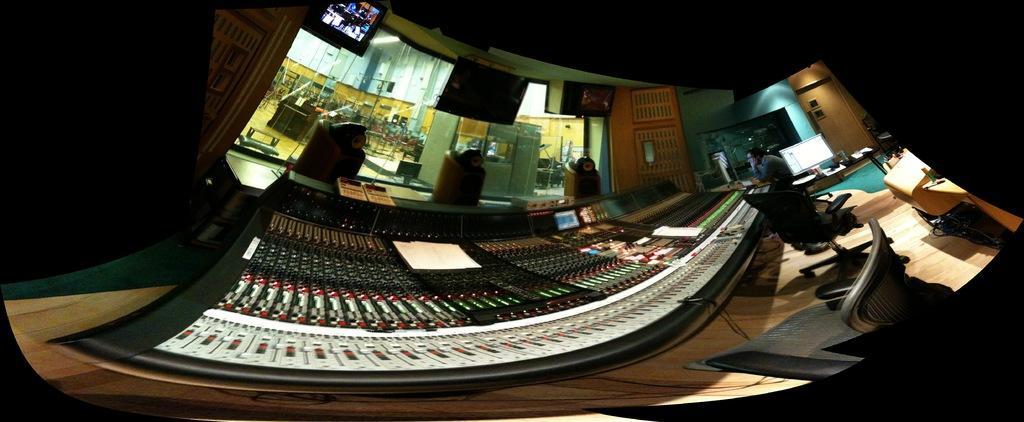Can you describe this image briefly? In this picture we can see a person and chairs on the floor, here we can see screens, wall and some objects. 